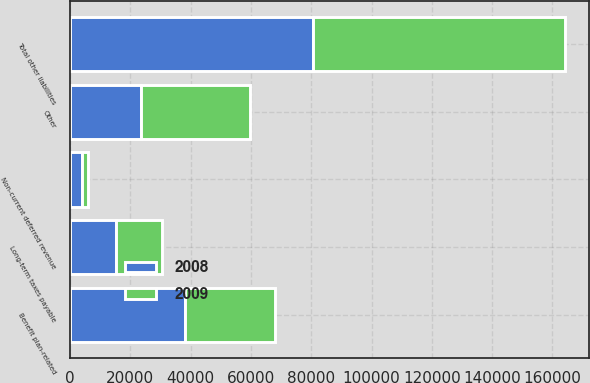<chart> <loc_0><loc_0><loc_500><loc_500><stacked_bar_chart><ecel><fcel>Non-current deferred revenue<fcel>Long-term taxes payable<fcel>Benefit plan-related<fcel>Other<fcel>Total other liabilities<nl><fcel>2008<fcel>3912<fcel>15064<fcel>37977<fcel>23618<fcel>80571<nl><fcel>2009<fcel>1913<fcel>15386<fcel>30098<fcel>36075<fcel>83472<nl></chart> 